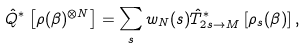<formula> <loc_0><loc_0><loc_500><loc_500>\hat { Q } ^ { * } \left [ \rho ( \beta ) ^ { \otimes N } \right ] = \sum _ { s } w _ { N } ( s ) \hat { T } ^ { * } _ { 2 s \to M } \left [ \rho _ { s } ( \beta ) \right ] ,</formula> 